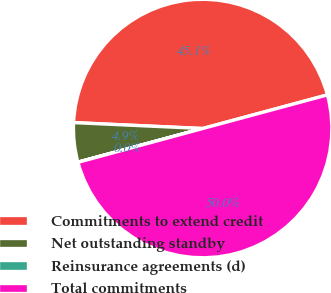<chart> <loc_0><loc_0><loc_500><loc_500><pie_chart><fcel>Commitments to extend credit<fcel>Net outstanding standby<fcel>Reinsurance agreements (d)<fcel>Total commitments<nl><fcel>45.08%<fcel>4.92%<fcel>0.02%<fcel>49.98%<nl></chart> 